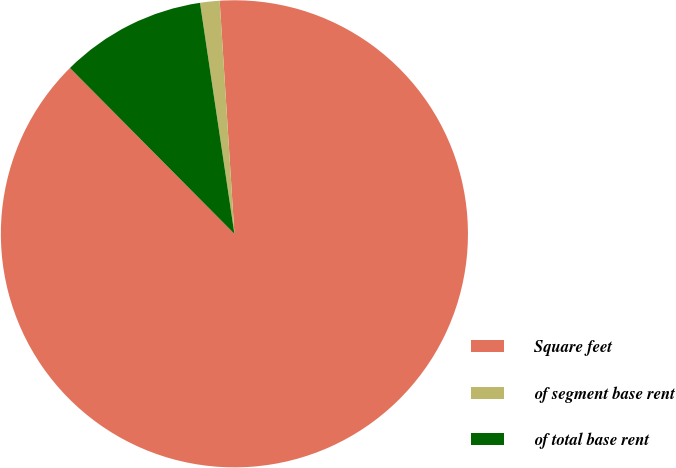Convert chart. <chart><loc_0><loc_0><loc_500><loc_500><pie_chart><fcel>Square feet<fcel>of segment base rent<fcel>of total base rent<nl><fcel>88.57%<fcel>1.35%<fcel>10.08%<nl></chart> 